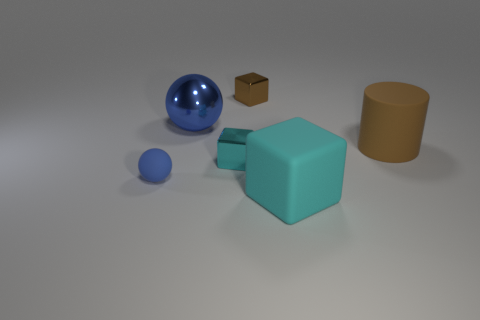Subtract all cyan blocks. How many blocks are left? 1 Add 4 large green matte objects. How many objects exist? 10 Subtract all cyan cubes. How many cubes are left? 1 Subtract 0 green cubes. How many objects are left? 6 Subtract all cylinders. How many objects are left? 5 Subtract 2 spheres. How many spheres are left? 0 Subtract all red spheres. Subtract all blue cylinders. How many spheres are left? 2 Subtract all purple cylinders. How many cyan blocks are left? 2 Subtract all big cylinders. Subtract all large matte objects. How many objects are left? 3 Add 2 large brown objects. How many large brown objects are left? 3 